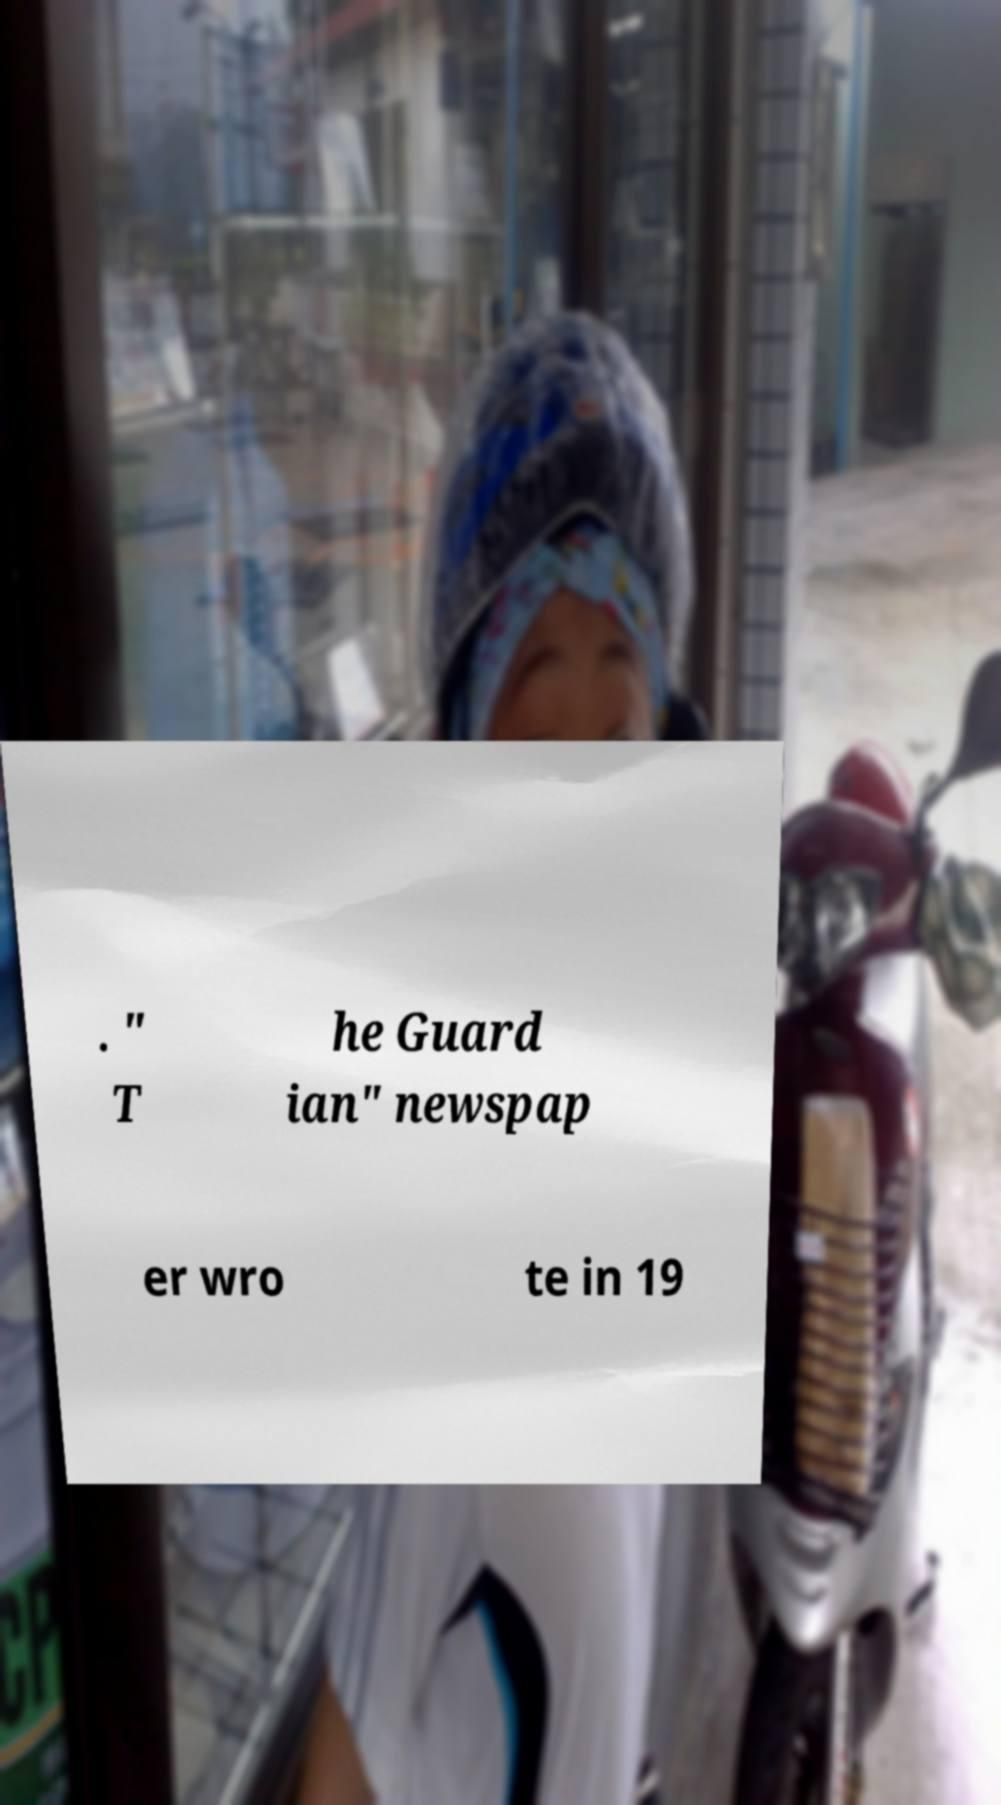What messages or text are displayed in this image? I need them in a readable, typed format. . " T he Guard ian" newspap er wro te in 19 